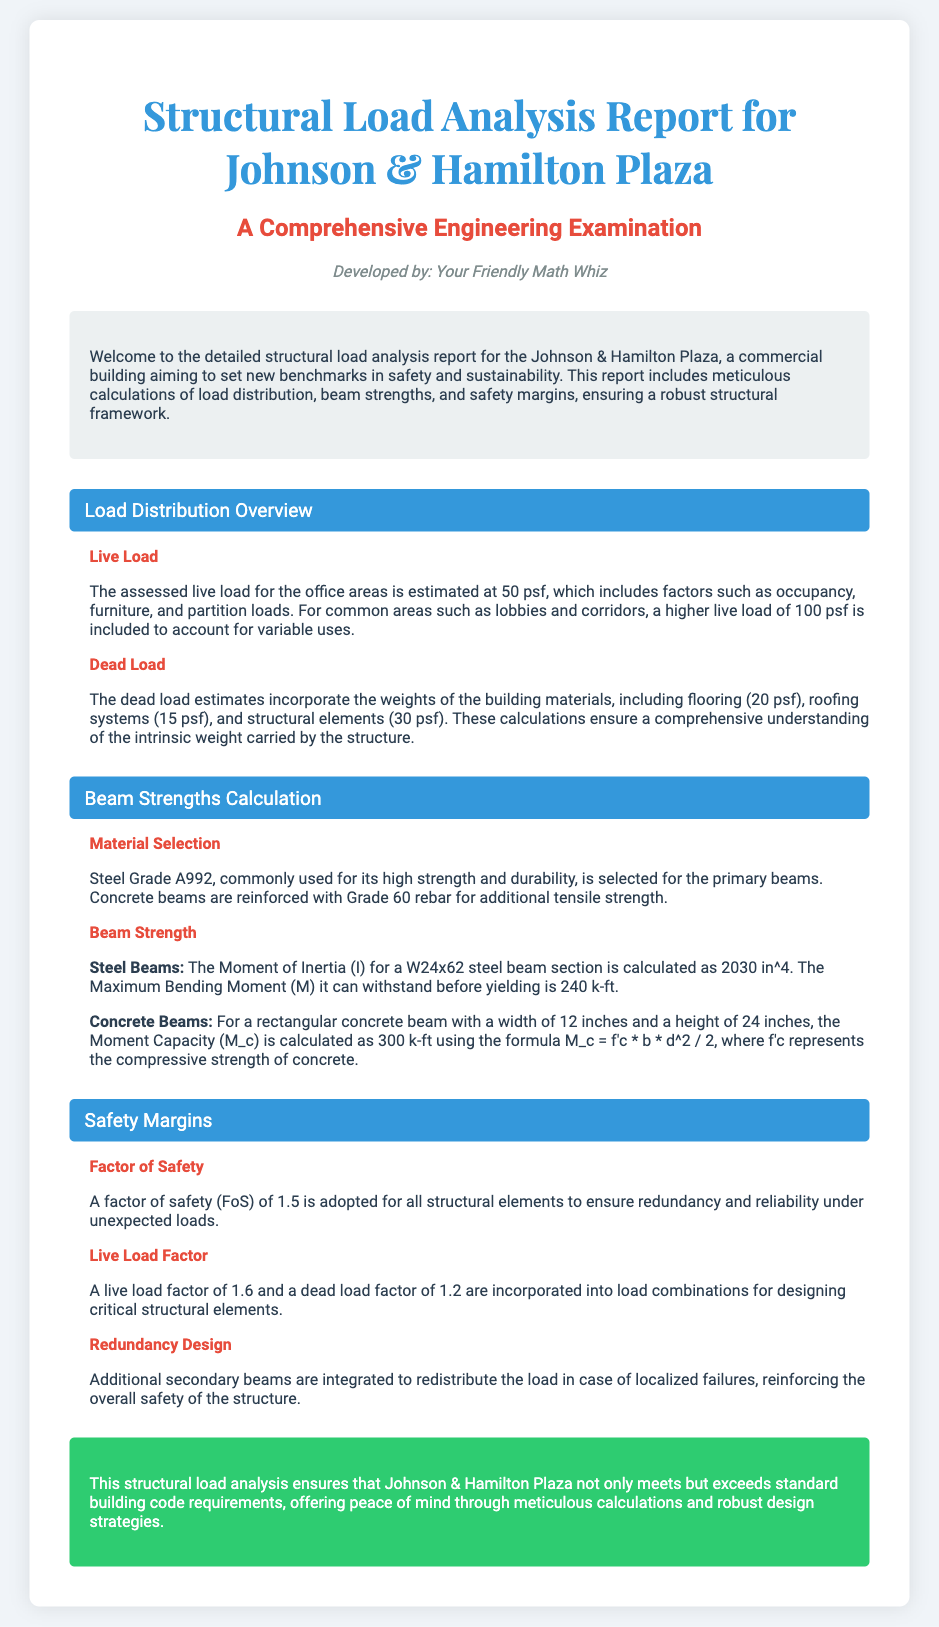what is the name of the plaza? The title mentions the Johnson & Hamilton Plaza, which is the focus of the structural load analysis report.
Answer: Johnson & Hamilton Plaza what is the assessed live load for office areas? The document states that the assessed live load for office areas is estimated at 50 psf.
Answer: 50 psf what material is selected for primary beams? The report specifies that Steel Grade A992 is selected for its high strength and durability for primary beams.
Answer: Steel Grade A992 what is the moment of inertia for a W24x62 steel beam? The document provides the Moment of Inertia (I) for a W24x62 steel beam section as 2030 in^4.
Answer: 2030 in^4 what factor of safety is adopted for structural elements? The document indicates that a factor of safety of 1.5 is adopted for all structural elements.
Answer: 1.5 how many psf is the live load for common areas? A higher live load of 100 psf is included for common areas according to the document.
Answer: 100 psf what is the maximum bending moment for steel beams? The maximum bending moment that steel beams can withstand is stated as 240 k-ft in the document.
Answer: 240 k-ft what safety margin design is implemented for localized failures? The report mentions that additional secondary beams are integrated to redistribute the load, which reinforces safety.
Answer: Redundancy Design what is the live load factor incorporated into load combinations? A live load factor of 1.6 is specified for designing critical structural elements in the document.
Answer: 1.6 